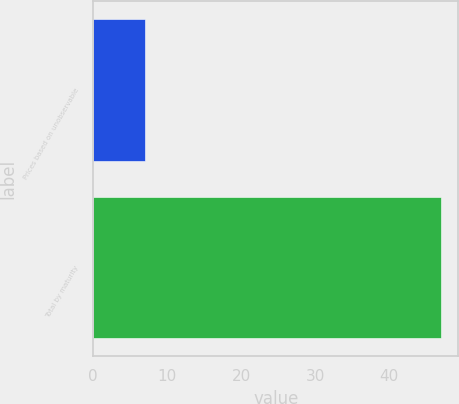Convert chart. <chart><loc_0><loc_0><loc_500><loc_500><bar_chart><fcel>Prices based on unobservable<fcel>Total by maturity<nl><fcel>7<fcel>47<nl></chart> 